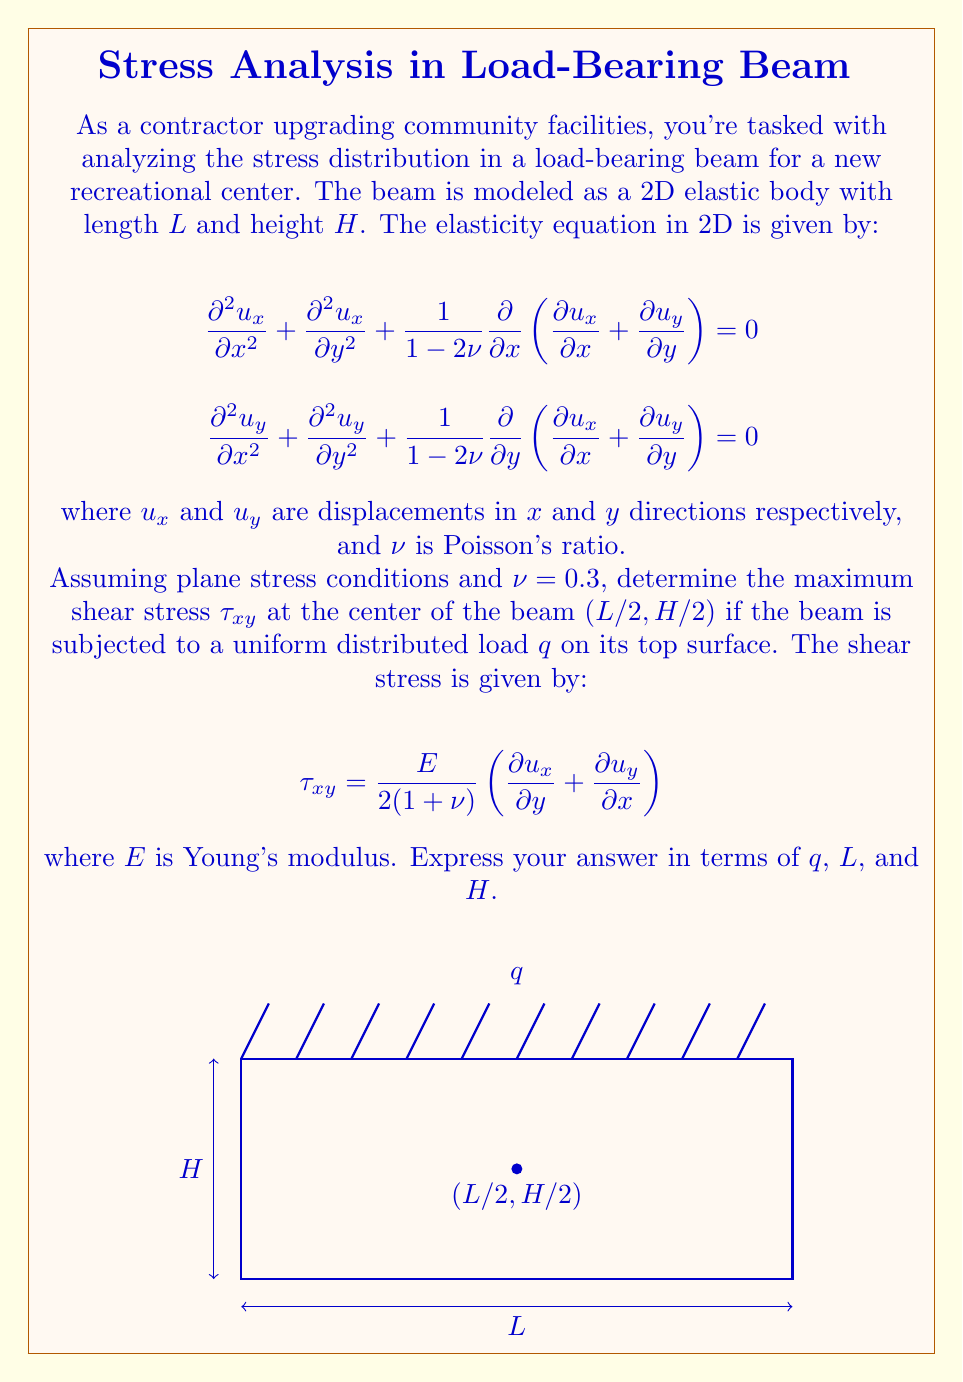Can you solve this math problem? To solve this problem, we'll follow these steps:

1) For a beam under uniform load, the shear stress distribution is parabolic across the height. The maximum shear stress occurs at the neutral axis (center) of the beam.

2) The shear stress at any point in the beam can be expressed as:

   $$\tau_{xy} = \frac{VQ}{It}$$

   where $V$ is the shear force, $Q$ is the first moment of area, $I$ is the moment of inertia, and $t$ is the width of the beam.

3) For a rectangular beam:
   - $V = q(L/2)$ at the center of the beam
   - $Q = \frac{1}{8}bH^2$ at the neutral axis, where $b$ is the width of the beam
   - $I = \frac{1}{12}bH^3$

4) Substituting these into the shear stress equation:

   $$\tau_{xy} = \frac{q(L/2) \cdot \frac{1}{8}bH^2}{\frac{1}{12}bH^3 \cdot b} = \frac{3qL}{4H}$$

5) This is the maximum shear stress at the center of the beam.

6) Note that this result is independent of Young's modulus $E$ and Poisson's ratio $\nu$, which would be needed if we were calculating displacements or normal stresses.
Answer: $\tau_{xy,max} = \frac{3qL}{4H}$ 